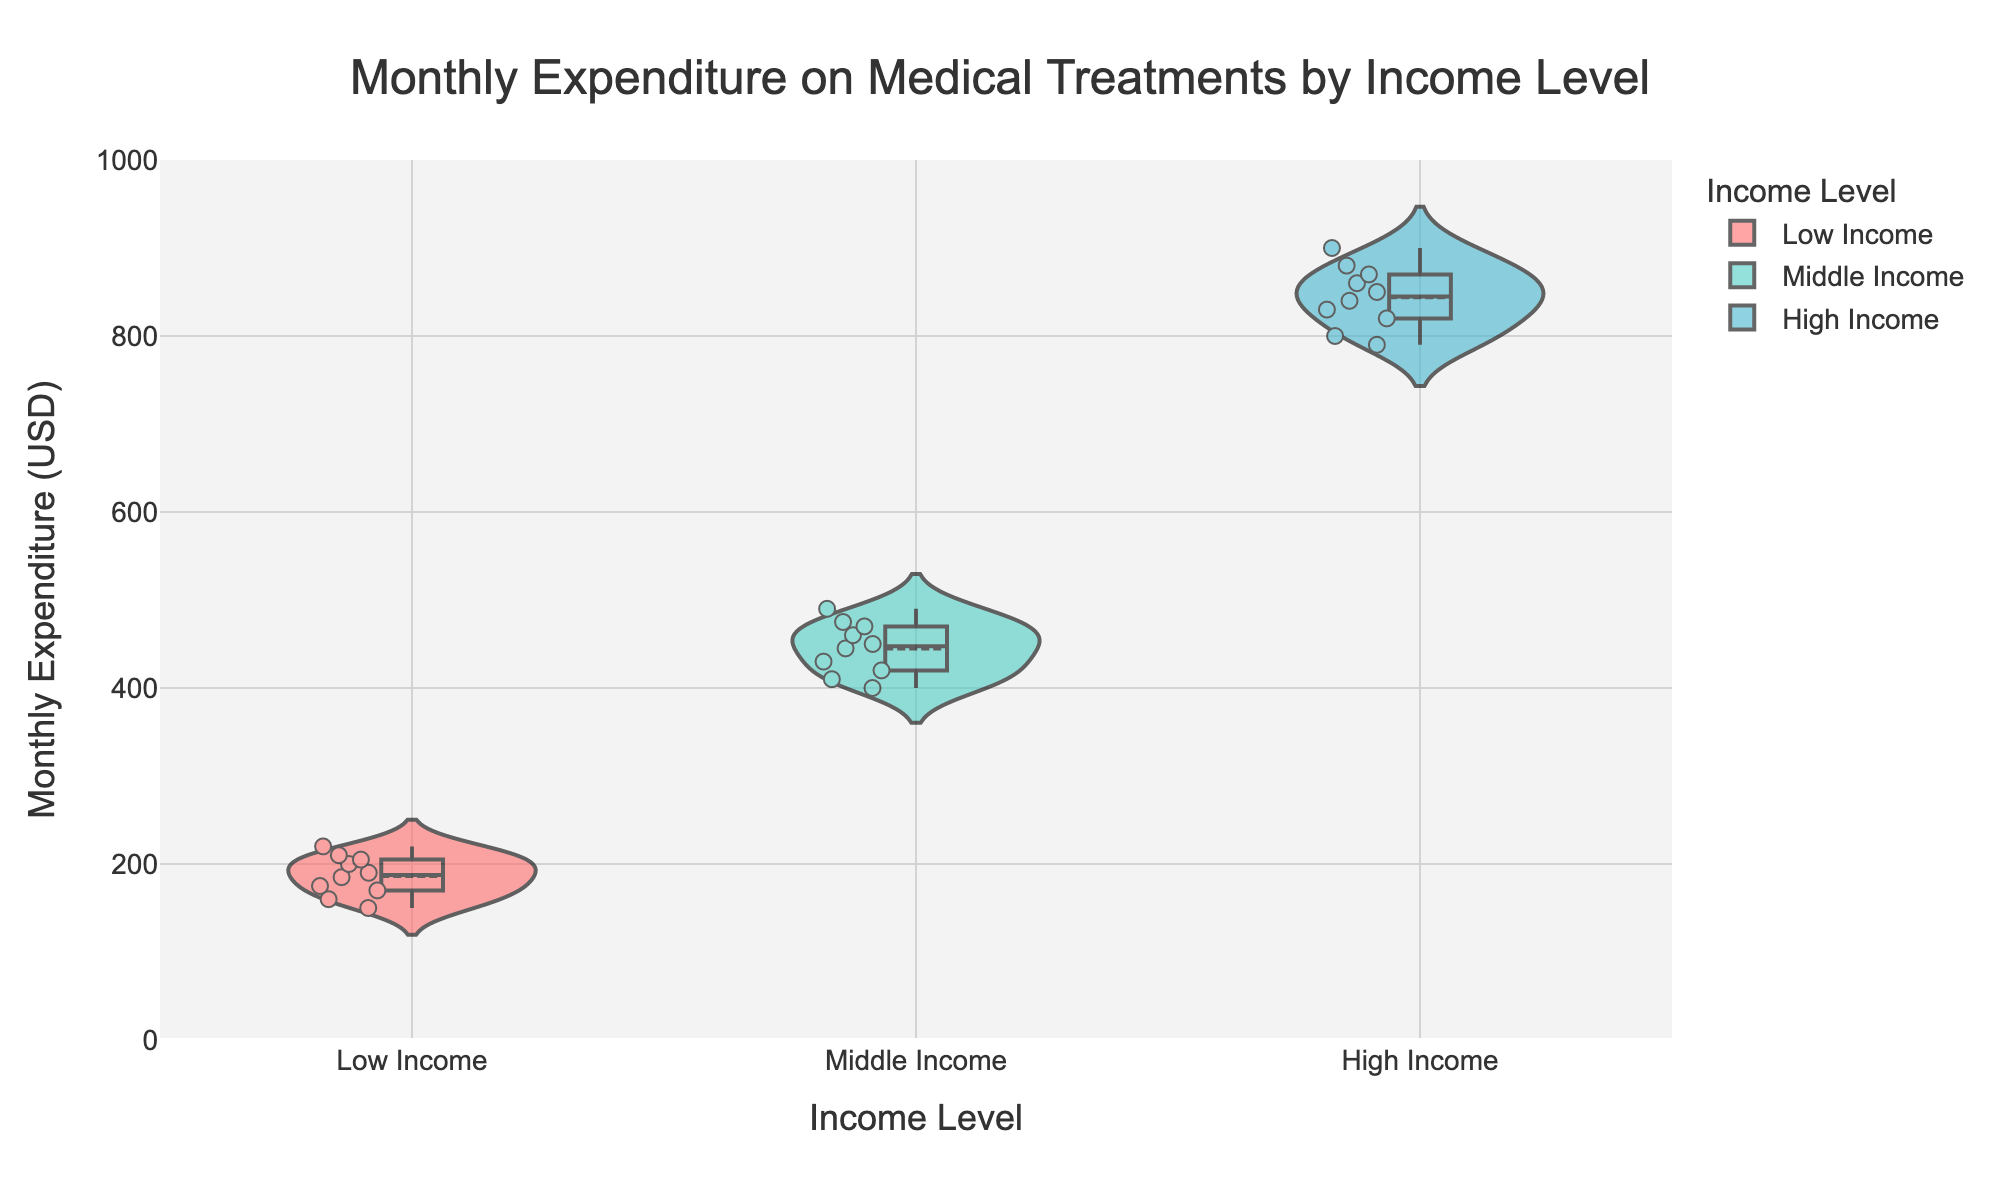What is the title of this chart? The title is commonly displayed at the top of a chart. In this chart, it reads "Monthly Expenditure on Medical Treatments by Income Level".
Answer: Monthly Expenditure on Medical Treatments by Income Level Which income level has the lowest median monthly expenditure on treatments and therapies? In violin plots, the median is usually indicated by a horizontal line within the plot. Observing the plot, the lowest median is seen in the "Low Income" group.
Answer: Low Income What is the approximate median monthly expenditure for the High Income group? The median is typically represented by a horizontal line within the violin plot. For the High Income group, this line is around $840.
Answer: $840 How many income levels are represented in the chart? The income levels are represented along the x-axis of the chart. There are three distinct income levels: Low Income, Middle Income, and High Income.
Answer: 3 Which income category shows the highest variability in monthly expenditure on treatments? Variability in a violin plot can be assessed by the spread of the distribution. The High Income group shows a wider spread compared to the others, indicating higher variability.
Answer: High Income Are there any data points that are outliers in the Middle Income group, and if so, how many? Outliers in violin plots are typically indicated by jittered points outside the main distribution area. In this chart, there are no clear points significantly detached from the main spread for the Middle Income group.
Answer: No Which income level shows the smallest range in monthly expenditure on treatments? The range of values can be observed by the length from the uppermost to the lowermost point in the violin plot. The Low Income group has the smallest range.
Answer: Low Income How does the average monthly expenditure in the Low Income group compare to the High Income group? The average can be inferred from the meanline visible in the violin plot. Comparing these, the High Income group has a significantly higher average expenditure than the Low Income group.
Answer: High Income is higher 